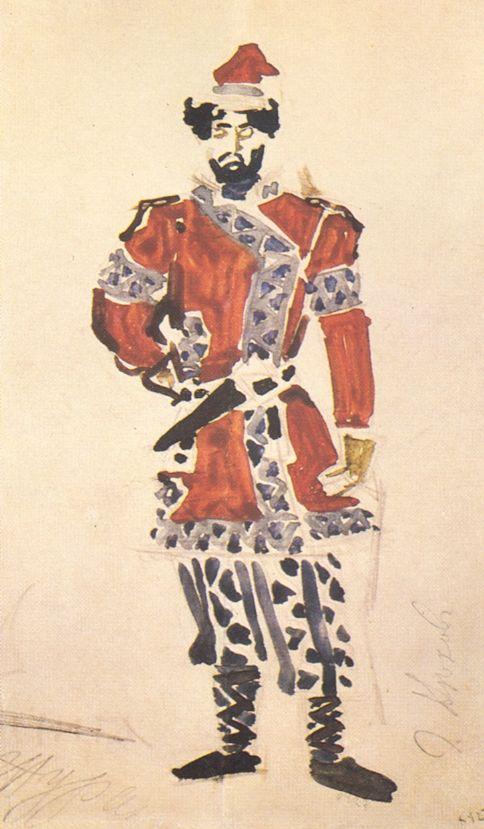Can you explain the significance of the patterns on the uniform? The intricate patterns on the soldier's uniform are likely indicative of specific military regalia associated with his rank and unit. In historical military uniforms, such patterns often incorporated unit insignia or national symbols, tailored to signify allegiance and service. These details not only served a decorative purpose but also communicated the soldier's achievements and standing within the military hierarchy, playing a vital role in his identification and distinction among peers. 